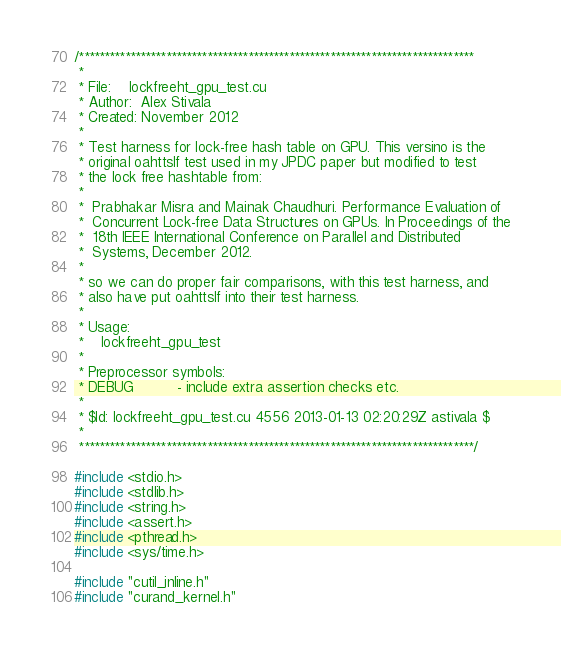<code> <loc_0><loc_0><loc_500><loc_500><_Cuda_>/*****************************************************************************
 * 
 * File:    lockfreeht_gpu_test.cu
 * Author:  Alex Stivala
 * Created: November 2012
 *
 * Test harness for lock-free hash table on GPU. This versino is the
 * original oahttslf test used in my JPDC paper but modified to test
 * the lock free hashtable from:
 *
 *  Prabhakar Misra and Mainak Chaudhuri. Performance Evaluation of
 *  Concurrent Lock-free Data Structures on GPUs. In Proceedings of the
 *  18th IEEE International Conference on Parallel and Distributed
 *  Systems, December 2012.
 *
 * so we can do proper fair comparisons, with this test harness, and
 * also have put oahttslf into their test harness.
 * 
 * Usage:
 *    lockfreeht_gpu_test
 *
 * Preprocessor symbols:
 * DEBUG          - include extra assertion checks etc.
 *
 * $Id: lockfreeht_gpu_test.cu 4556 2013-01-13 02:20:29Z astivala $
 *
 *****************************************************************************/

#include <stdio.h>
#include <stdlib.h>
#include <string.h>
#include <assert.h>
#include <pthread.h>
#include <sys/time.h>

#include "cutil_inline.h"
#include "curand_kernel.h"
</code> 